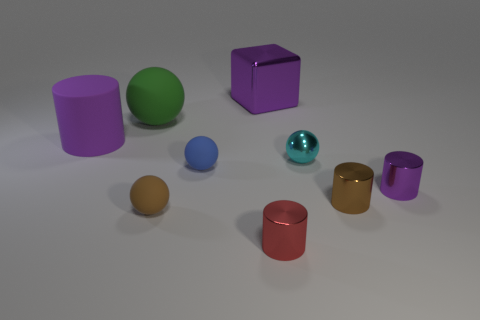Subtract all large purple cylinders. How many cylinders are left? 3 Subtract all cyan blocks. How many purple cylinders are left? 2 Subtract 2 balls. How many balls are left? 2 Subtract all brown cylinders. How many cylinders are left? 3 Subtract all spheres. How many objects are left? 5 Subtract all red spheres. Subtract all brown cylinders. How many spheres are left? 4 Subtract all gray rubber things. Subtract all big matte spheres. How many objects are left? 8 Add 5 red cylinders. How many red cylinders are left? 6 Add 3 tiny metal things. How many tiny metal things exist? 7 Subtract 0 green blocks. How many objects are left? 9 